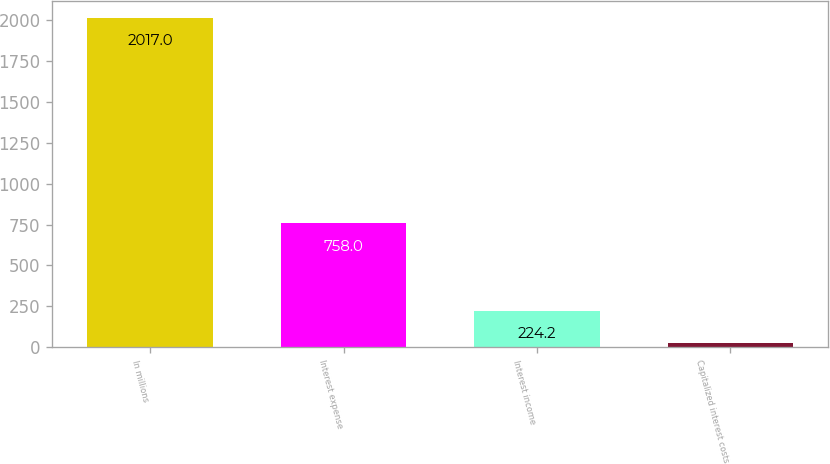Convert chart to OTSL. <chart><loc_0><loc_0><loc_500><loc_500><bar_chart><fcel>In millions<fcel>Interest expense<fcel>Interest income<fcel>Capitalized interest costs<nl><fcel>2017<fcel>758<fcel>224.2<fcel>25<nl></chart> 